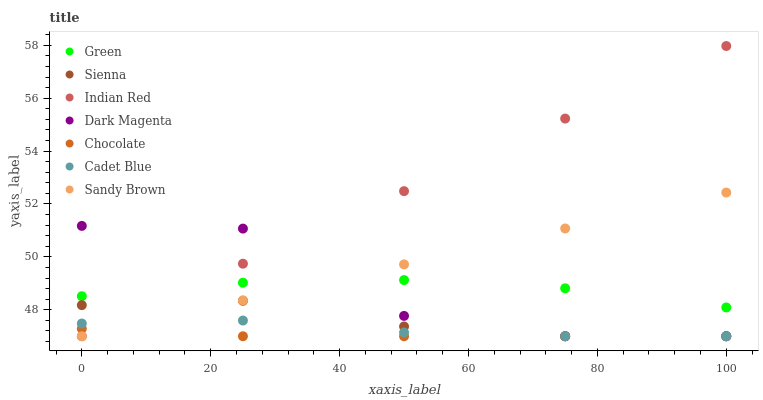Does Chocolate have the minimum area under the curve?
Answer yes or no. Yes. Does Indian Red have the maximum area under the curve?
Answer yes or no. Yes. Does Dark Magenta have the minimum area under the curve?
Answer yes or no. No. Does Dark Magenta have the maximum area under the curve?
Answer yes or no. No. Is Indian Red the smoothest?
Answer yes or no. Yes. Is Dark Magenta the roughest?
Answer yes or no. Yes. Is Chocolate the smoothest?
Answer yes or no. No. Is Chocolate the roughest?
Answer yes or no. No. Does Cadet Blue have the lowest value?
Answer yes or no. Yes. Does Green have the lowest value?
Answer yes or no. No. Does Indian Red have the highest value?
Answer yes or no. Yes. Does Dark Magenta have the highest value?
Answer yes or no. No. Is Cadet Blue less than Green?
Answer yes or no. Yes. Is Green greater than Chocolate?
Answer yes or no. Yes. Does Chocolate intersect Sienna?
Answer yes or no. Yes. Is Chocolate less than Sienna?
Answer yes or no. No. Is Chocolate greater than Sienna?
Answer yes or no. No. Does Cadet Blue intersect Green?
Answer yes or no. No. 